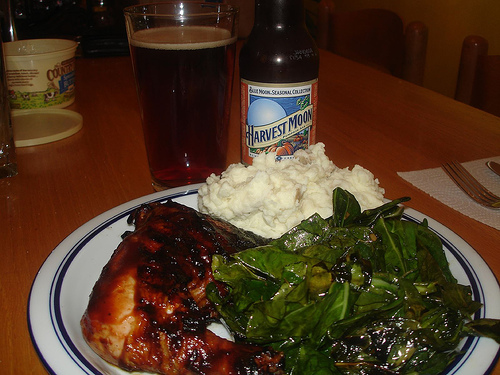<image>
Is the beer in the bottle? No. The beer is not contained within the bottle. These objects have a different spatial relationship. Where is the beer in relation to the potatos? Is it behind the potatos? Yes. From this viewpoint, the beer is positioned behind the potatos, with the potatos partially or fully occluding the beer. 